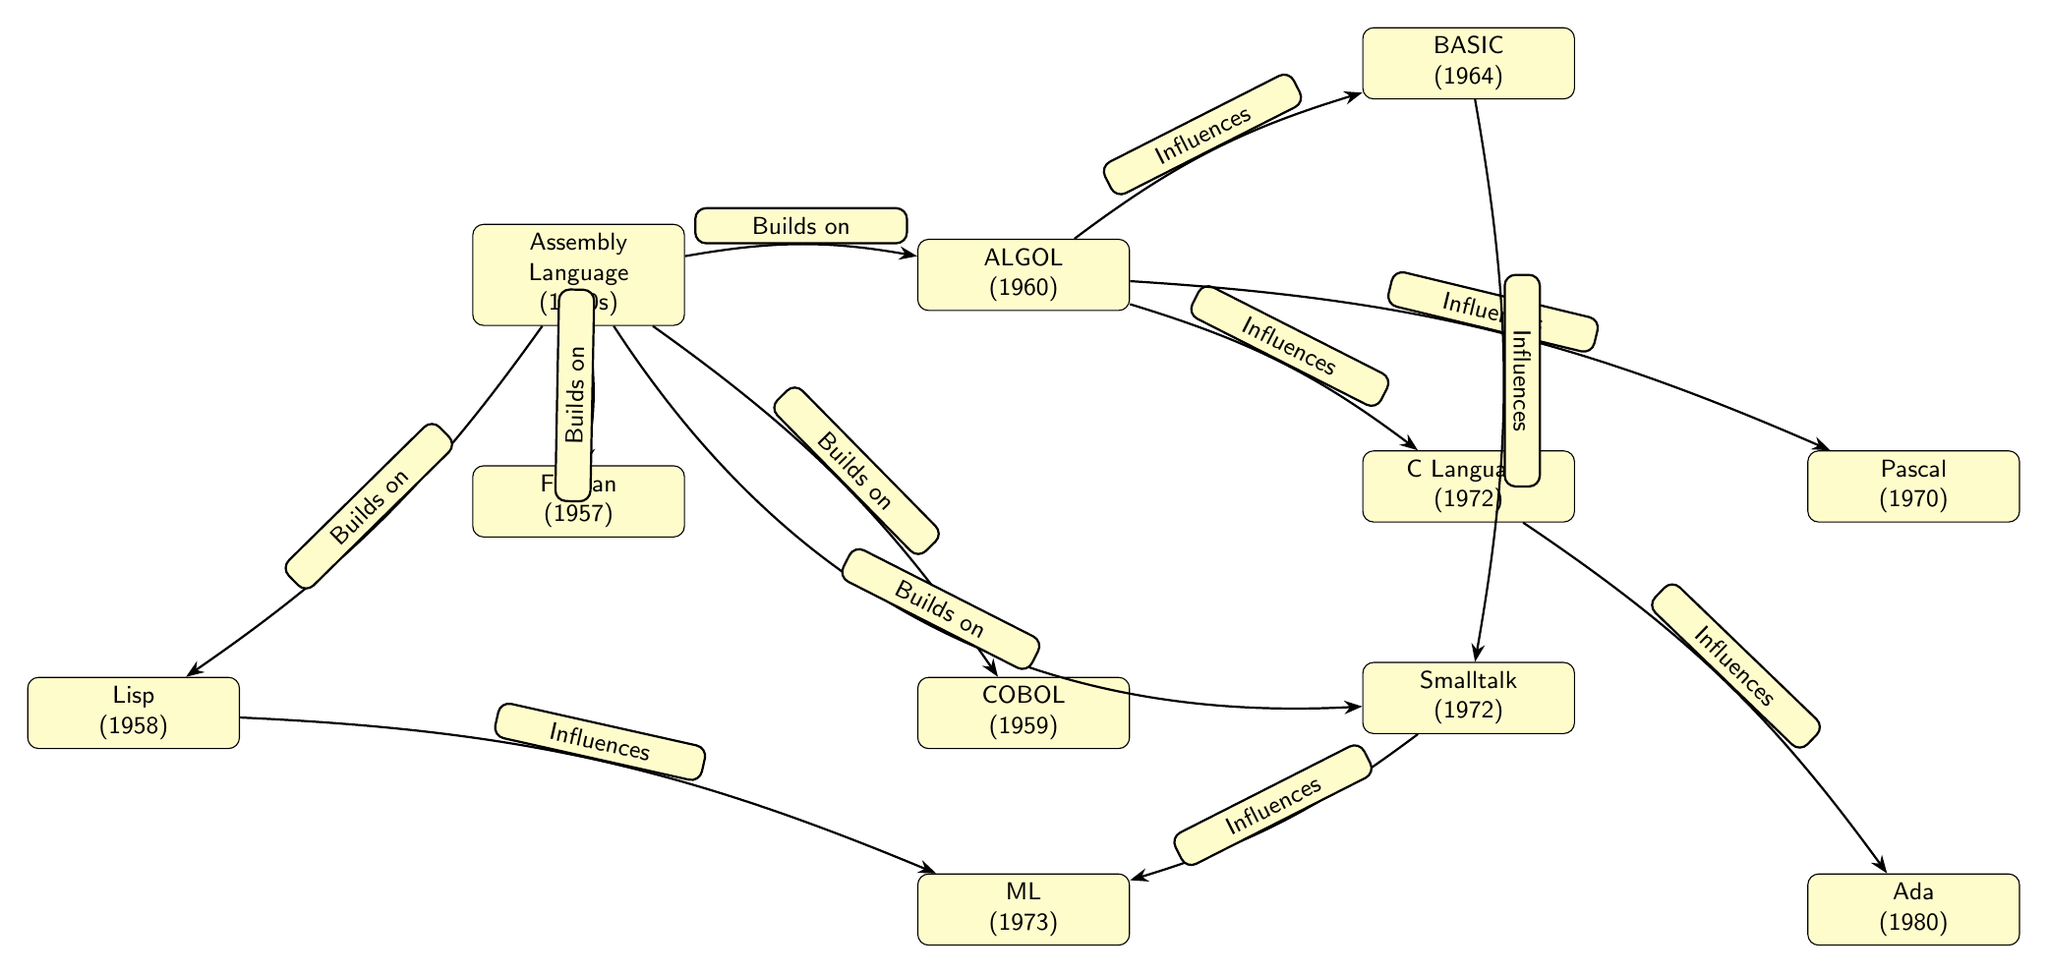What programming language was introduced first in the diagram? The diagram lists programming languages chronologically. The first language indicated is Assembly Language, which dates back to the 1950s.
Answer: Assembly Language How many programming languages are represented in the diagram? Counting all the nodes in the diagram, there are ten programming languages represented: Assembly Language, Fortran, Lisp, COBOL, ALGOL, BASIC, C Language, Pascal, Smalltalk, ML, and Ada.
Answer: Ten Which programming language did ALGOL influence according to the diagram? The diagram shows directed edges indicating influence. ALGOL has arrows pointing towards BASIC, C Language, and Pascal, meaning it influenced each of these languages.
Answer: BASIC, C Language, Pascal What is the relationship between Smalltalk and ML? The diagram indicates a directed influence from both Lisp and Smalltalk to the ML node. This suggests that both languages played a role in helping develop the ML programming language.
Answer: Influences Which programming languages were built on Assembly Language? The diagram shows edges labeled "Builds on" connecting Assembly Language to Fortran, Lisp, COBOL, ALGOL, and Smalltalk, indicating these languages were developed based on Assembly Language.
Answer: Fortran, Lisp, COBOL, ALGOL, Smalltalk 